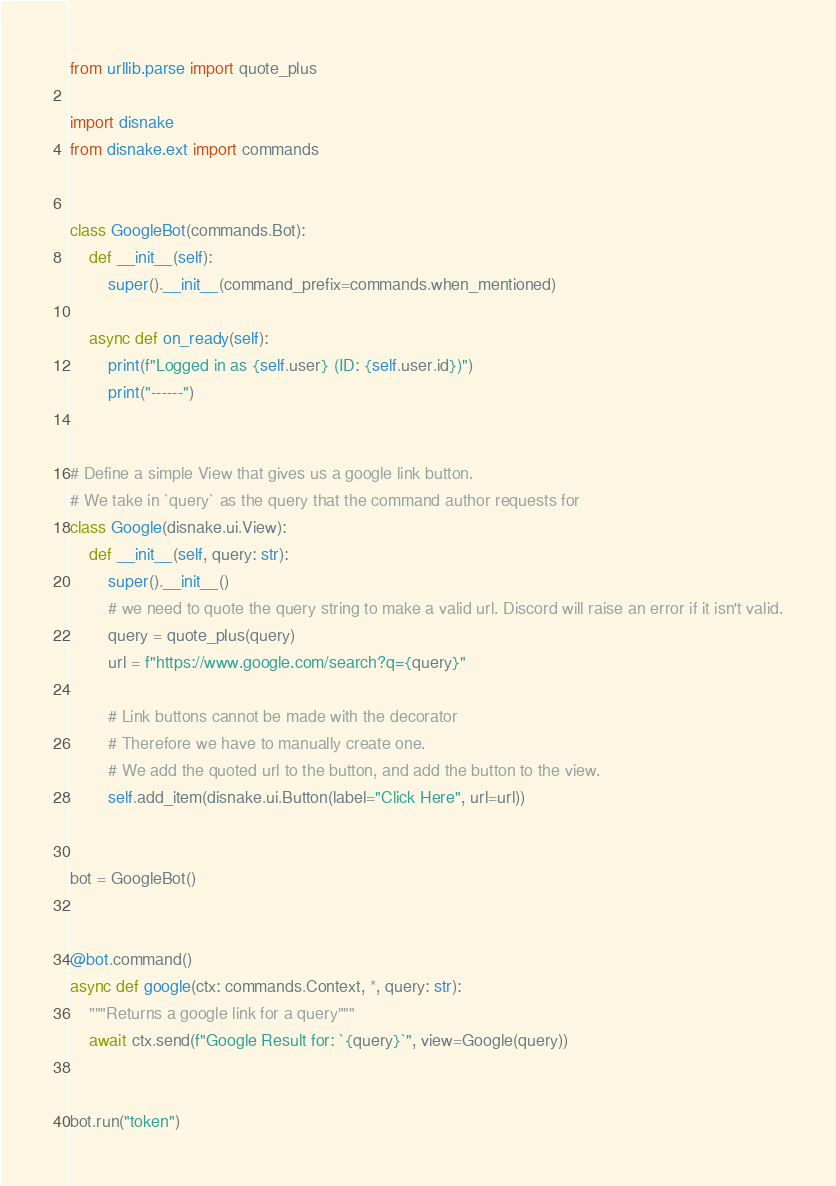Convert code to text. <code><loc_0><loc_0><loc_500><loc_500><_Python_>from urllib.parse import quote_plus

import disnake
from disnake.ext import commands


class GoogleBot(commands.Bot):
    def __init__(self):
        super().__init__(command_prefix=commands.when_mentioned)

    async def on_ready(self):
        print(f"Logged in as {self.user} (ID: {self.user.id})")
        print("------")


# Define a simple View that gives us a google link button.
# We take in `query` as the query that the command author requests for
class Google(disnake.ui.View):
    def __init__(self, query: str):
        super().__init__()
        # we need to quote the query string to make a valid url. Discord will raise an error if it isn't valid.
        query = quote_plus(query)
        url = f"https://www.google.com/search?q={query}"

        # Link buttons cannot be made with the decorator
        # Therefore we have to manually create one.
        # We add the quoted url to the button, and add the button to the view.
        self.add_item(disnake.ui.Button(label="Click Here", url=url))


bot = GoogleBot()


@bot.command()
async def google(ctx: commands.Context, *, query: str):
    """Returns a google link for a query"""
    await ctx.send(f"Google Result for: `{query}`", view=Google(query))


bot.run("token")
</code> 